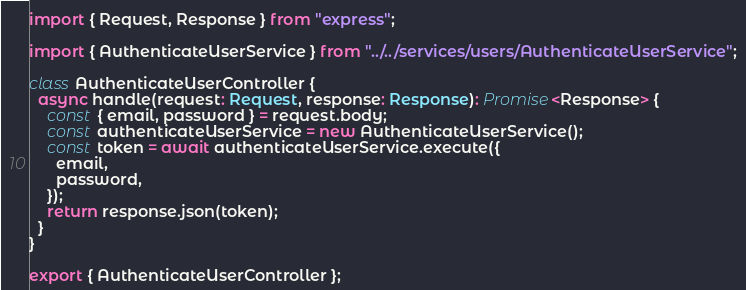<code> <loc_0><loc_0><loc_500><loc_500><_TypeScript_>import { Request, Response } from "express";

import { AuthenticateUserService } from "../../services/users/AuthenticateUserService";

class AuthenticateUserController {
  async handle(request: Request, response: Response): Promise<Response> {
    const { email, password } = request.body;
    const authenticateUserService = new AuthenticateUserService();
    const token = await authenticateUserService.execute({
      email,
      password,
    });
    return response.json(token);
  }
}

export { AuthenticateUserController };
</code> 